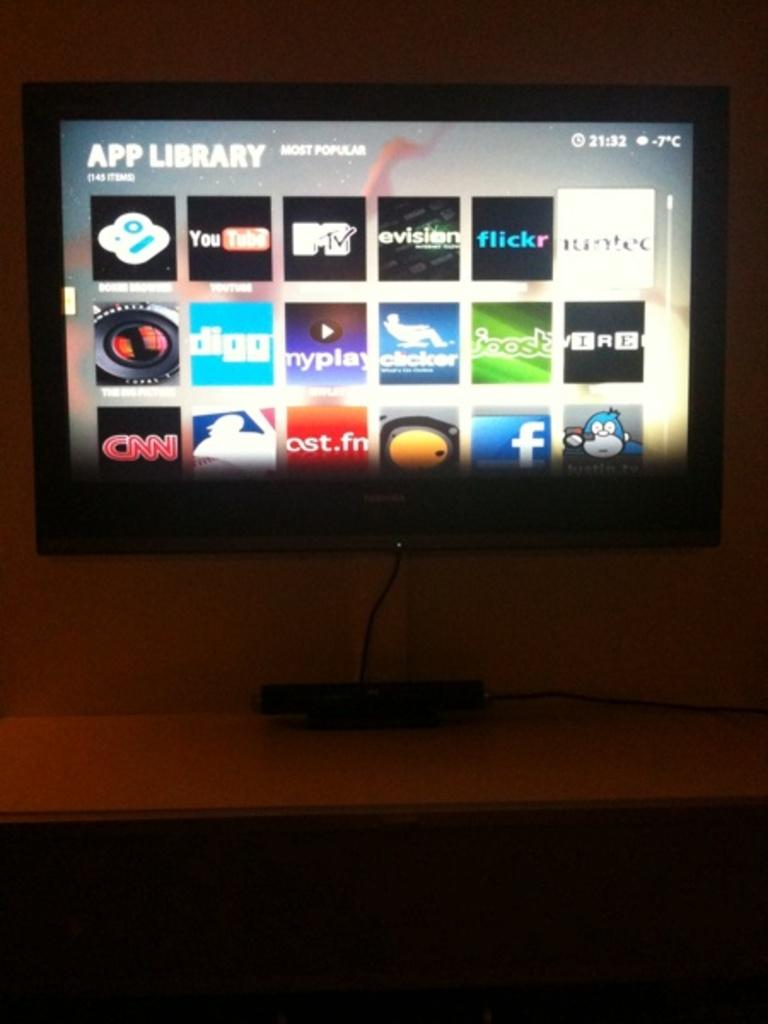<image>
Render a clear and concise summary of the photo. a clock that says 21:32 on the front of it 